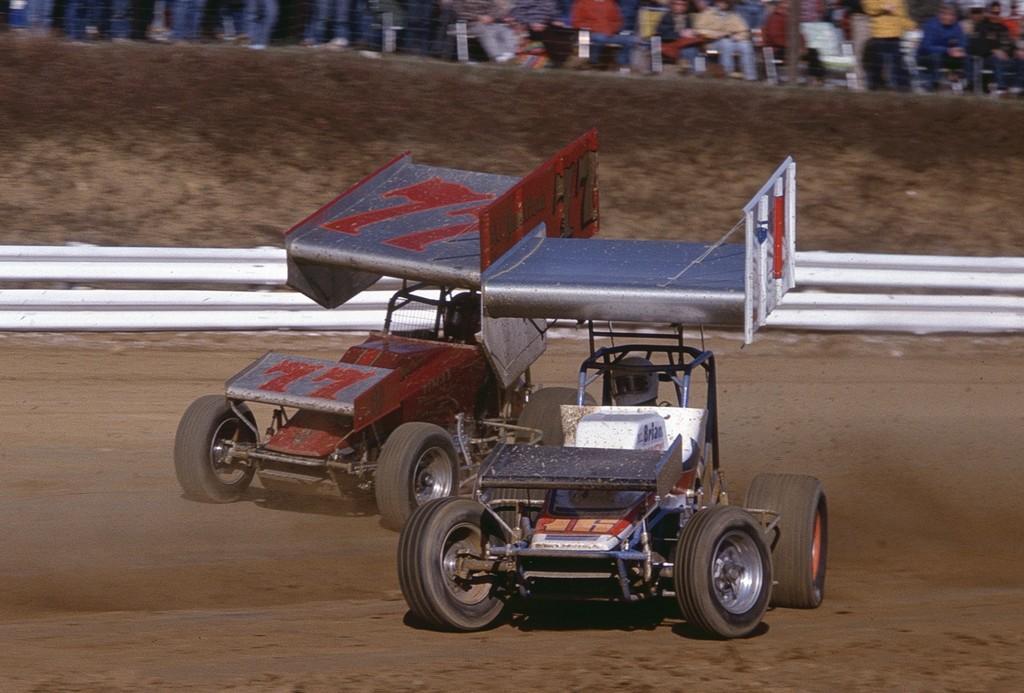How would you summarize this image in a sentence or two? In the center of the image we can see vehicles. In the background there is crowd. 